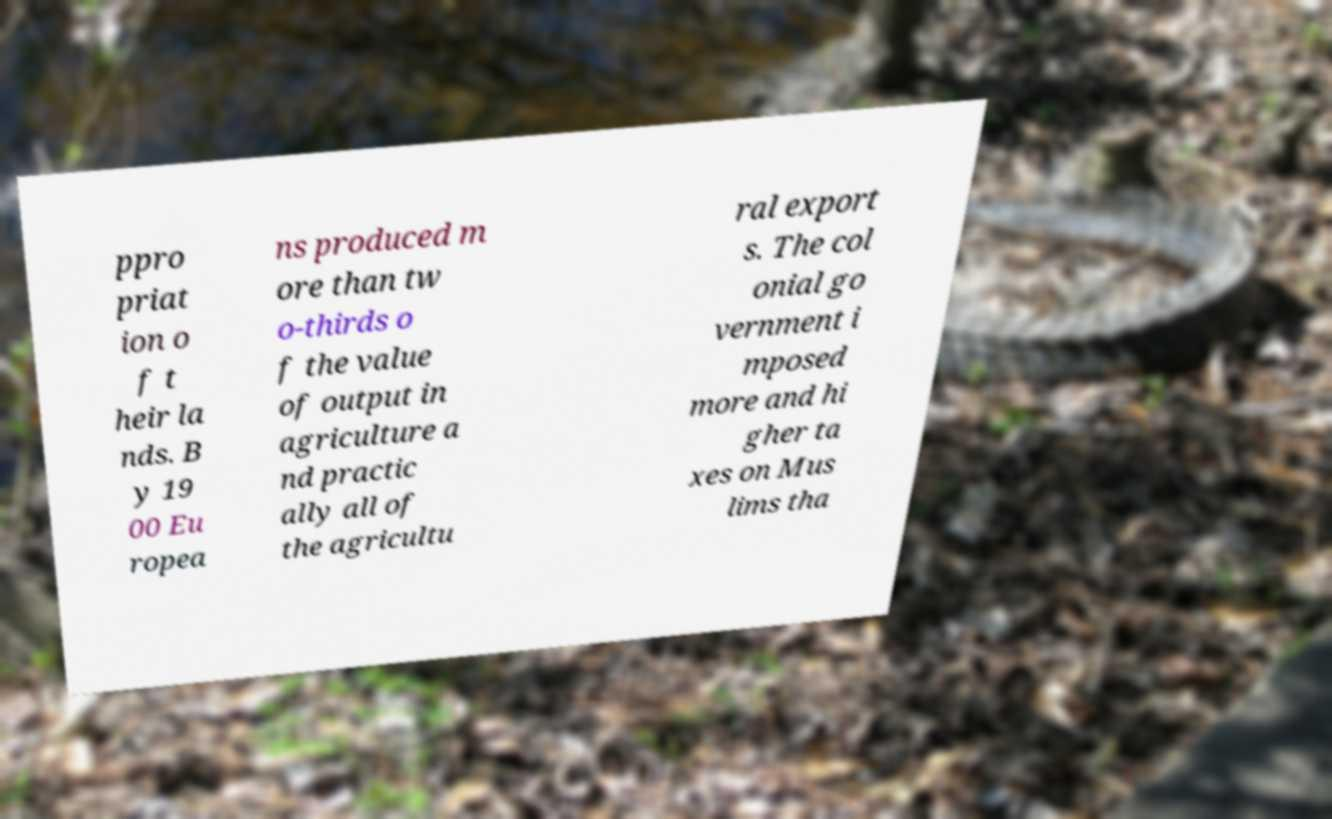Could you extract and type out the text from this image? ppro priat ion o f t heir la nds. B y 19 00 Eu ropea ns produced m ore than tw o-thirds o f the value of output in agriculture a nd practic ally all of the agricultu ral export s. The col onial go vernment i mposed more and hi gher ta xes on Mus lims tha 